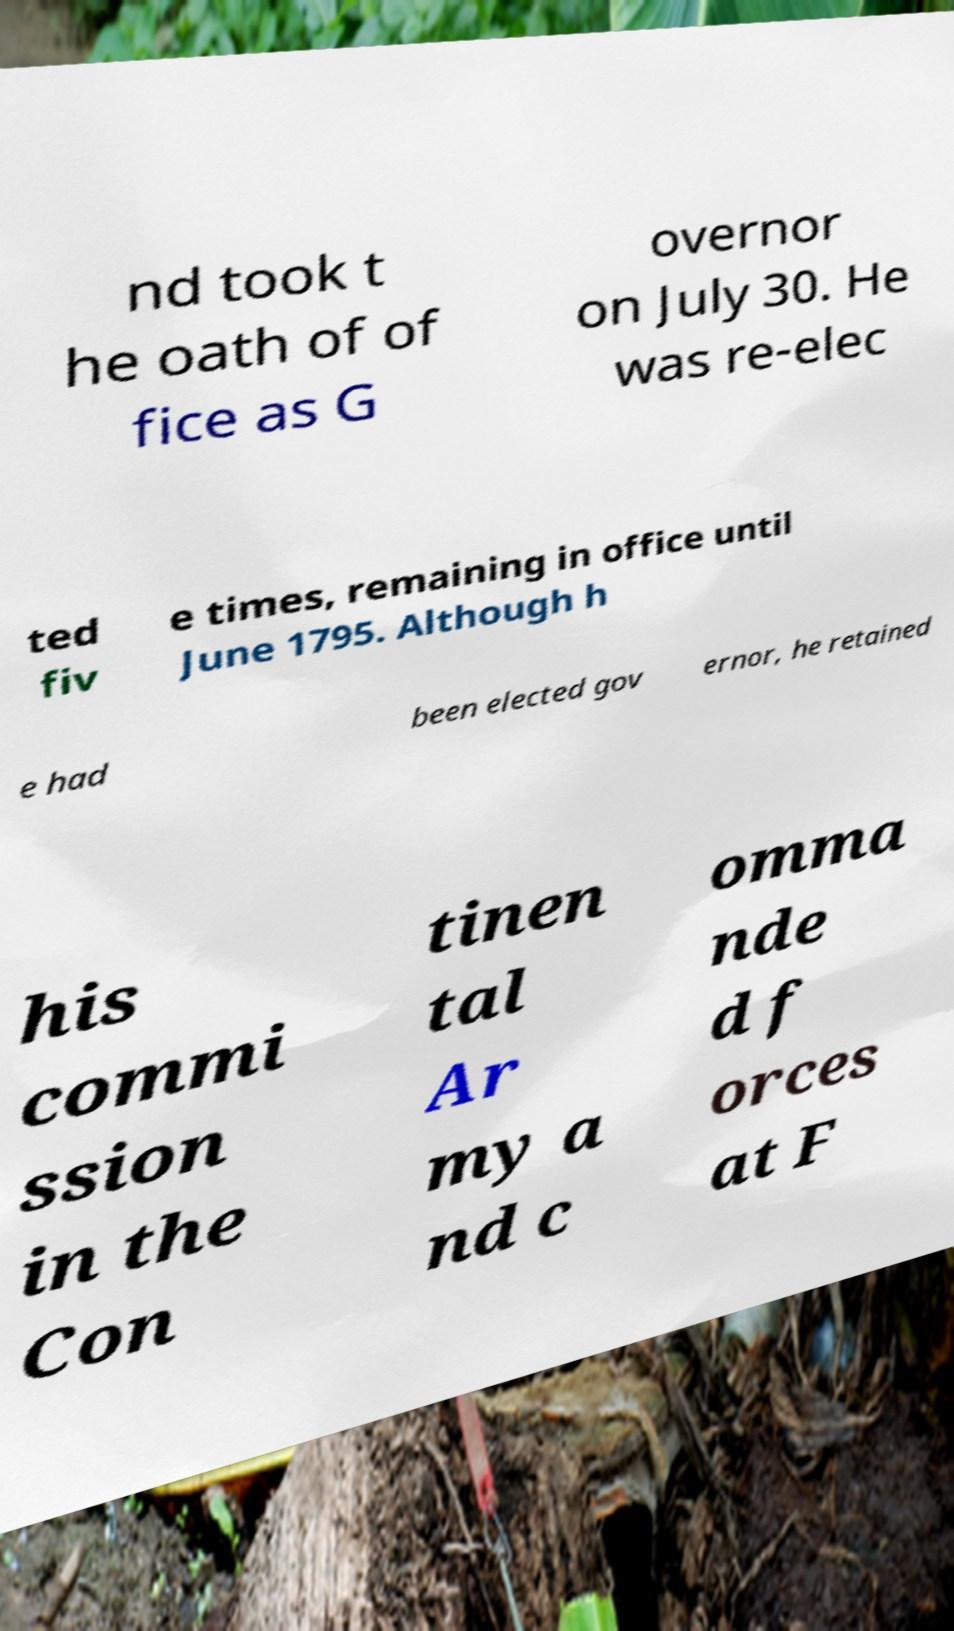Could you assist in decoding the text presented in this image and type it out clearly? nd took t he oath of of fice as G overnor on July 30. He was re-elec ted fiv e times, remaining in office until June 1795. Although h e had been elected gov ernor, he retained his commi ssion in the Con tinen tal Ar my a nd c omma nde d f orces at F 